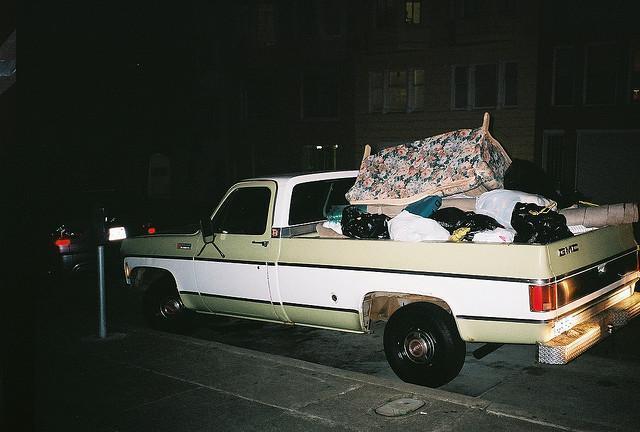Evaluate: Does the caption "The couch is on the truck." match the image?
Answer yes or no. Yes. Verify the accuracy of this image caption: "The truck is on the couch.".
Answer yes or no. No. Does the description: "The truck is far from the couch." accurately reflect the image?
Answer yes or no. No. 